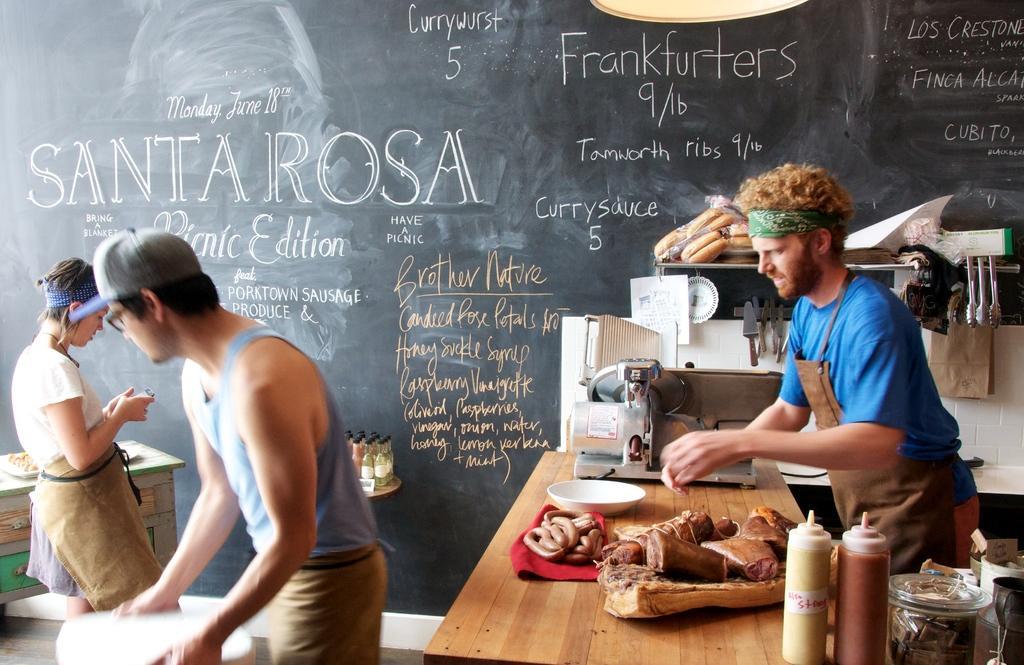Describe this image in one or two sentences. On the right there is a man who is standing near to the table. On the table we can see meet, hot dog, machine, ketchup bottles, jars and other objects. Beside him we can see hanger. In the bank there is a blackboard. On the left there is a woman who is looking on the phone and she is standing near to the desk. At the bottom there is a man who is wearing cap, spectacle, t-shirt and trouser. He is holding white plates. 